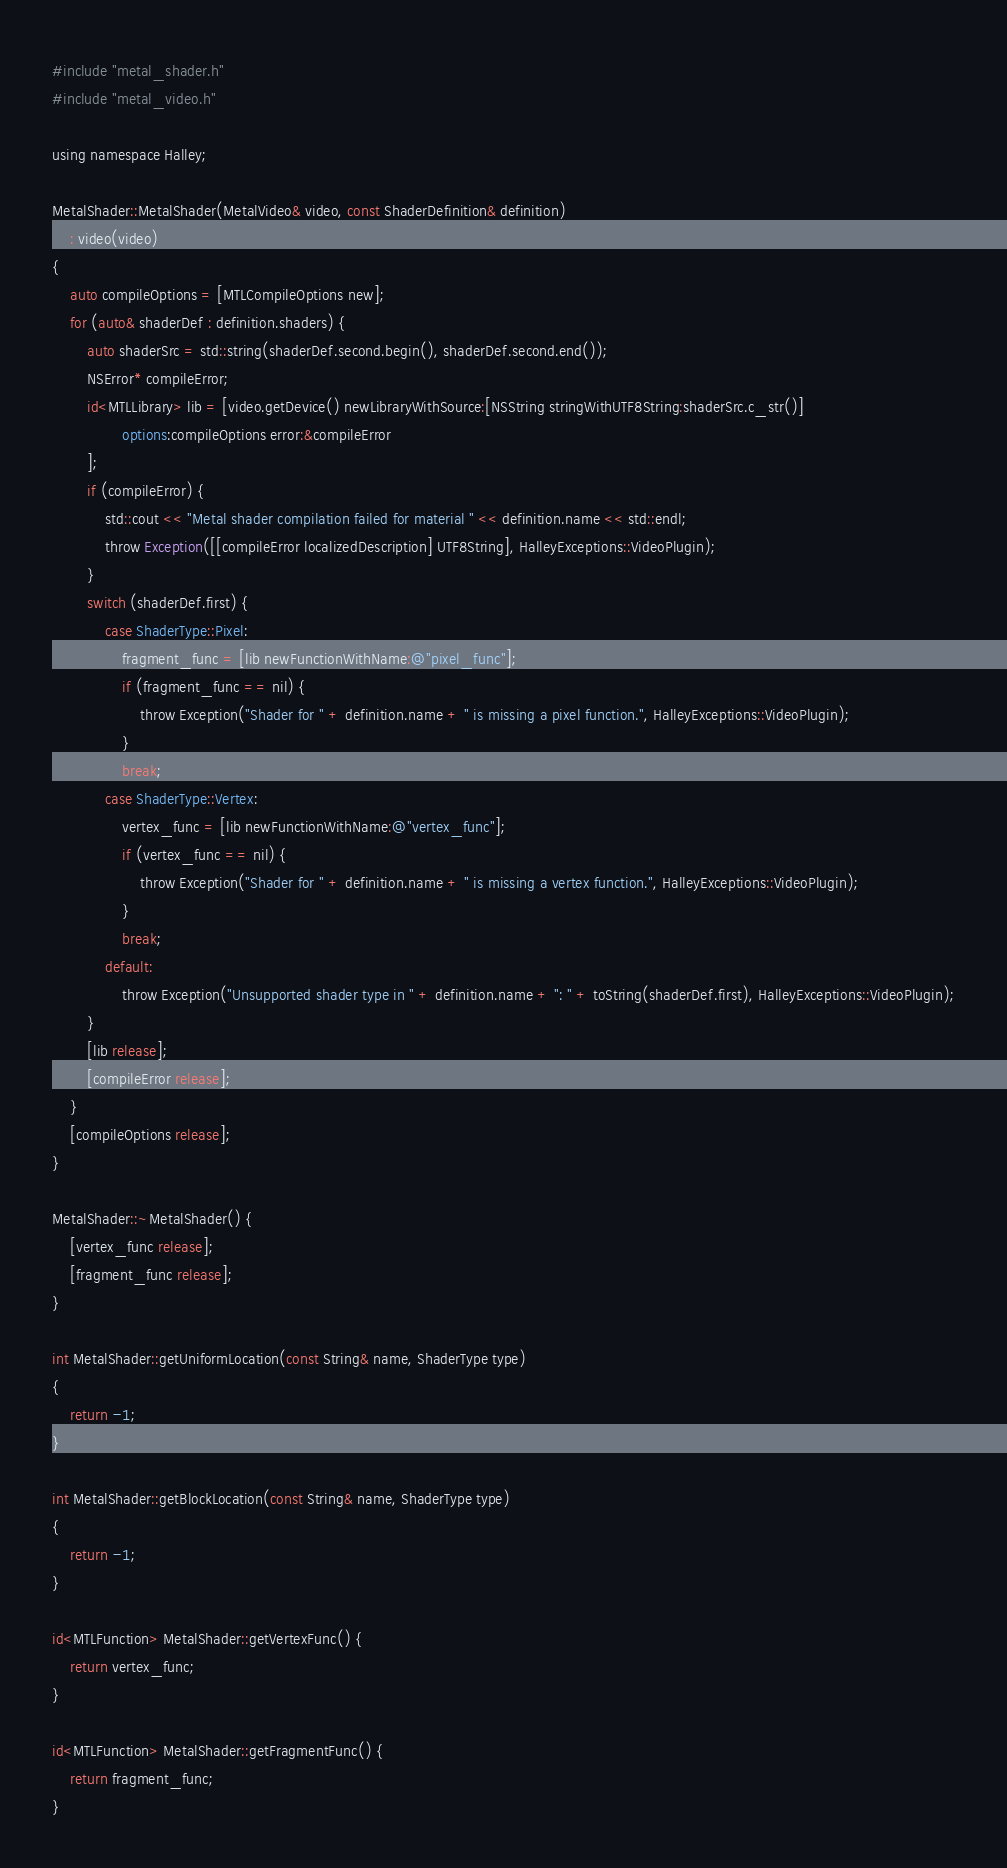<code> <loc_0><loc_0><loc_500><loc_500><_ObjectiveC_>#include "metal_shader.h"
#include "metal_video.h"

using namespace Halley;

MetalShader::MetalShader(MetalVideo& video, const ShaderDefinition& definition)
	: video(video)
{
	auto compileOptions = [MTLCompileOptions new];
	for (auto& shaderDef : definition.shaders) {
		auto shaderSrc = std::string(shaderDef.second.begin(), shaderDef.second.end());
		NSError* compileError;
		id<MTLLibrary> lib = [video.getDevice() newLibraryWithSource:[NSString stringWithUTF8String:shaderSrc.c_str()]
				options:compileOptions error:&compileError
		];
		if (compileError) {
			std::cout << "Metal shader compilation failed for material " << definition.name << std::endl;
			throw Exception([[compileError localizedDescription] UTF8String], HalleyExceptions::VideoPlugin);
		}
		switch (shaderDef.first) {
			case ShaderType::Pixel:
				fragment_func = [lib newFunctionWithName:@"pixel_func"];
				if (fragment_func == nil) {
					throw Exception("Shader for " + definition.name + " is missing a pixel function.", HalleyExceptions::VideoPlugin);
				}
				break;
			case ShaderType::Vertex:
				vertex_func = [lib newFunctionWithName:@"vertex_func"];
				if (vertex_func == nil) {
					throw Exception("Shader for " + definition.name + " is missing a vertex function.", HalleyExceptions::VideoPlugin);
				}
				break;
			default:
				throw Exception("Unsupported shader type in " + definition.name + ": " + toString(shaderDef.first), HalleyExceptions::VideoPlugin);
		}
		[lib release];
		[compileError release];
	}
	[compileOptions release];
}

MetalShader::~MetalShader() {
	[vertex_func release];
	[fragment_func release];
}

int MetalShader::getUniformLocation(const String& name, ShaderType type)
{
	return -1;
}

int MetalShader::getBlockLocation(const String& name, ShaderType type)
{
	return -1;
}

id<MTLFunction> MetalShader::getVertexFunc() {
	return vertex_func;
}

id<MTLFunction> MetalShader::getFragmentFunc() {
	return fragment_func;
}


</code> 